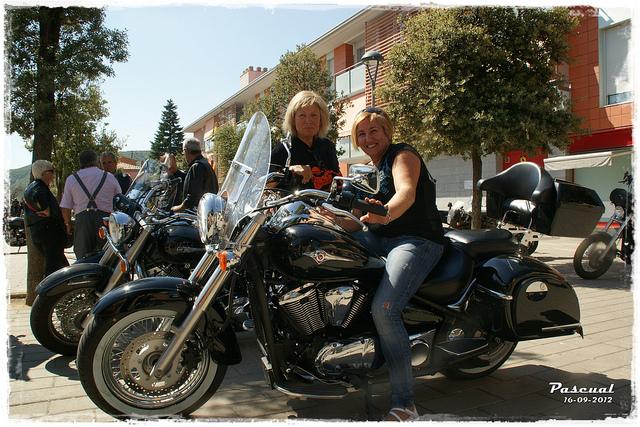What year was the photo taken?
Be succinct. 2012. What is this woman sitting on?
Write a very short answer. Motorcycle. What vehicle is shown?
Answer briefly. Motorcycle. 